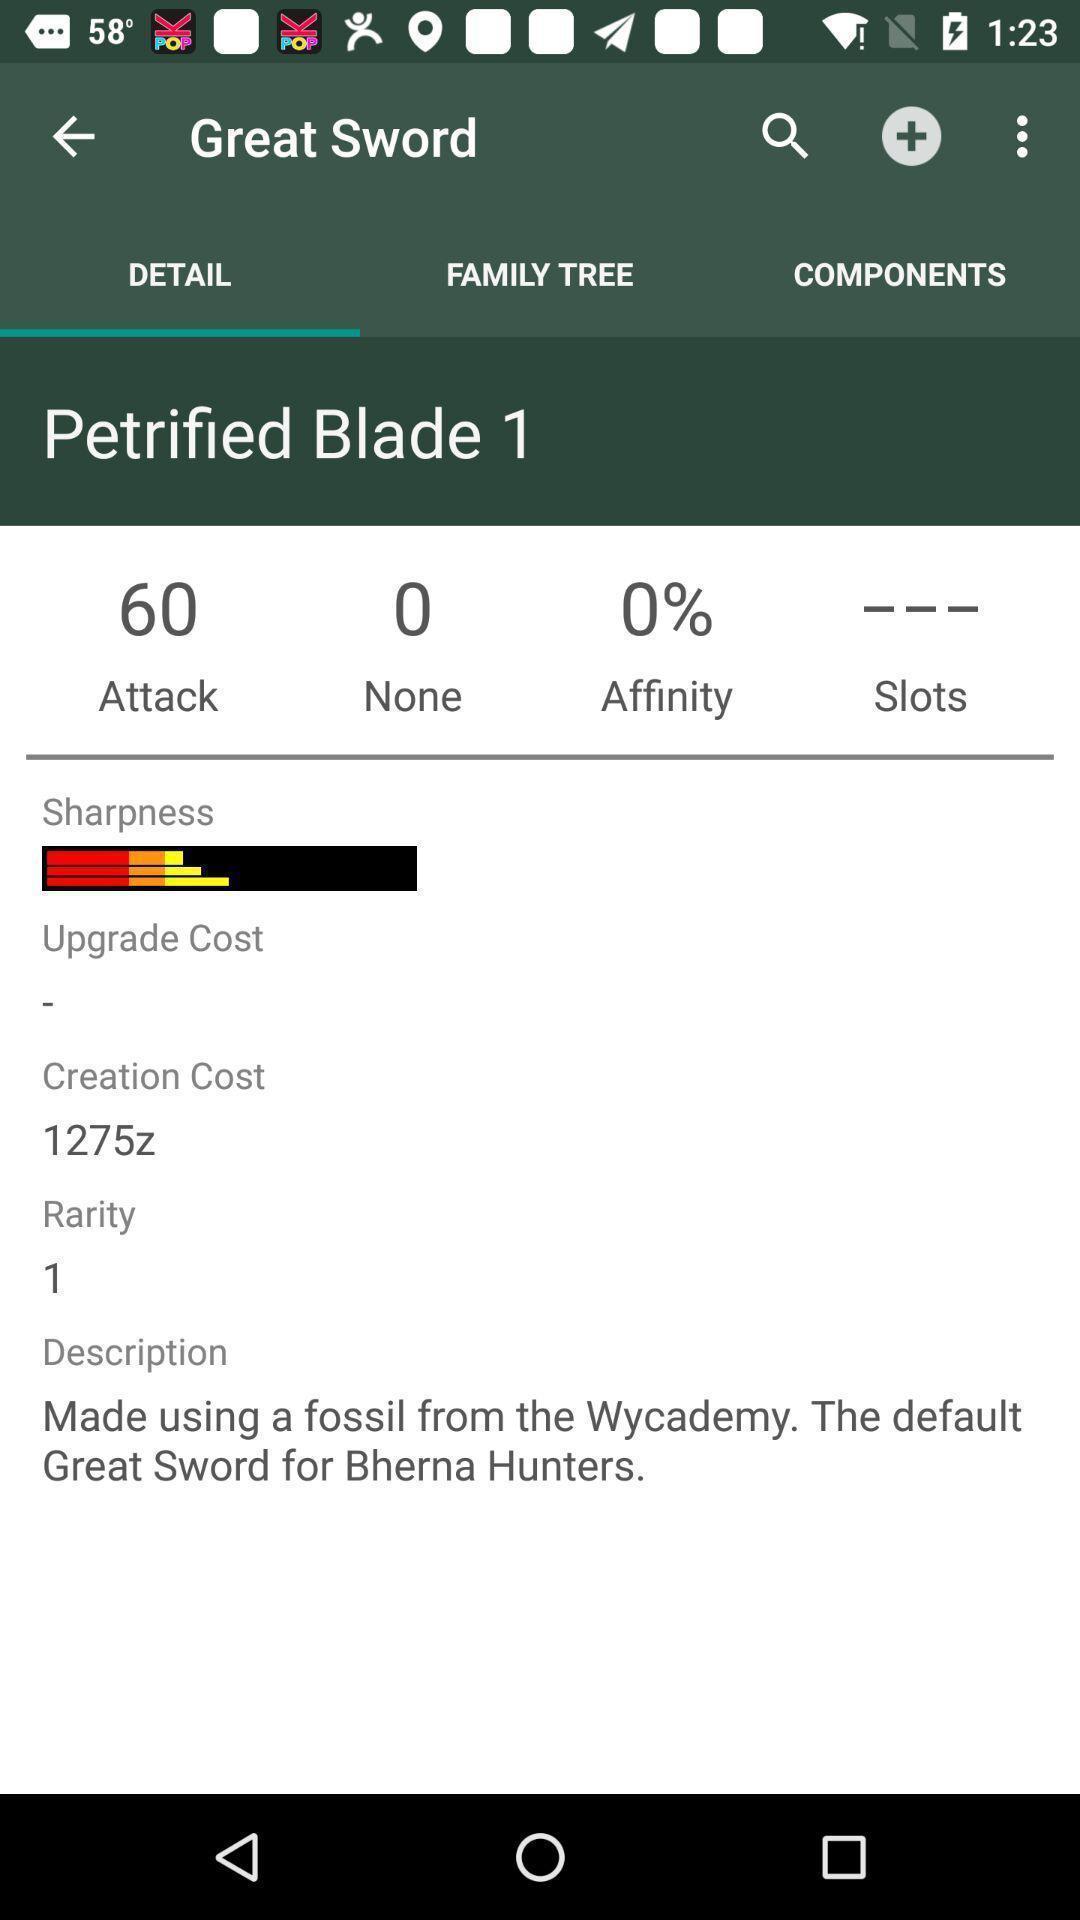Describe the content in this image. Page with details of a sword. 